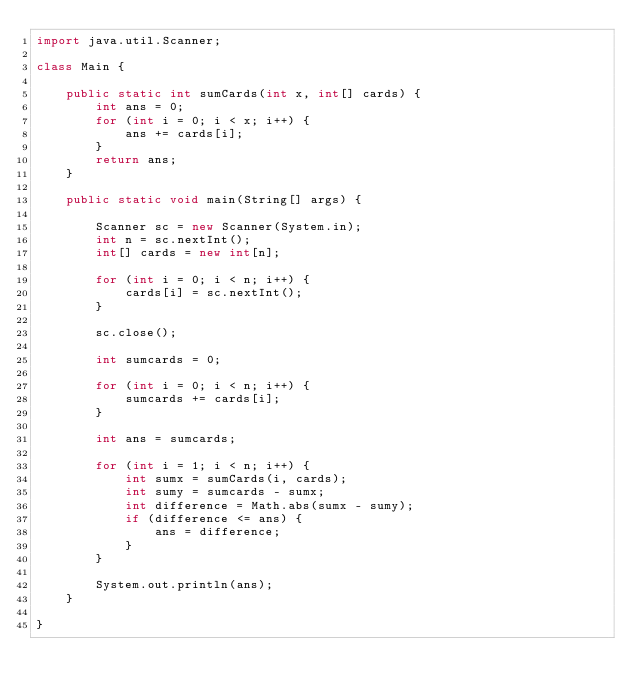Convert code to text. <code><loc_0><loc_0><loc_500><loc_500><_Java_>import java.util.Scanner;

class Main {
	
	public static int sumCards(int x, int[] cards) {
		int ans = 0;
		for (int i = 0; i < x; i++) {
			ans += cards[i];
		}
		return ans;
	}

	public static void main(String[] args) {
		
		Scanner sc = new Scanner(System.in);
		int n = sc.nextInt();
		int[] cards = new int[n];
		
		for (int i = 0; i < n; i++) {
			cards[i] = sc.nextInt();
		}
		
		sc.close();

		int sumcards = 0;
		
		for (int i = 0; i < n; i++) {
			sumcards += cards[i];
		}
		
		int ans = sumcards;
		
		for (int i = 1; i < n; i++) {
			int sumx = sumCards(i, cards);
			int sumy = sumcards - sumx;
			int difference = Math.abs(sumx - sumy);
			if (difference <= ans) {
				ans = difference;
			}
		}
		
		System.out.println(ans);
	}
	
}</code> 